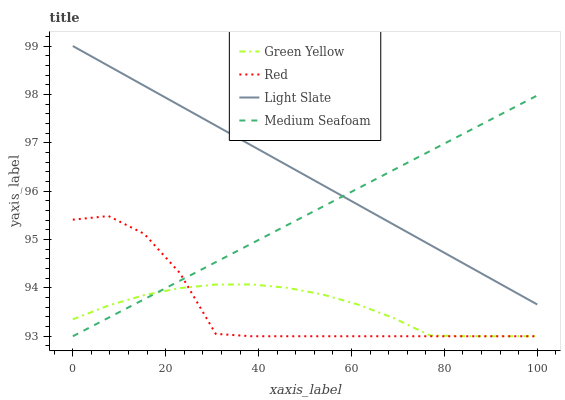Does Red have the minimum area under the curve?
Answer yes or no. Yes. Does Light Slate have the maximum area under the curve?
Answer yes or no. Yes. Does Green Yellow have the minimum area under the curve?
Answer yes or no. No. Does Green Yellow have the maximum area under the curve?
Answer yes or no. No. Is Medium Seafoam the smoothest?
Answer yes or no. Yes. Is Red the roughest?
Answer yes or no. Yes. Is Green Yellow the smoothest?
Answer yes or no. No. Is Green Yellow the roughest?
Answer yes or no. No. Does Green Yellow have the lowest value?
Answer yes or no. Yes. Does Light Slate have the highest value?
Answer yes or no. Yes. Does Medium Seafoam have the highest value?
Answer yes or no. No. Is Red less than Light Slate?
Answer yes or no. Yes. Is Light Slate greater than Green Yellow?
Answer yes or no. Yes. Does Red intersect Medium Seafoam?
Answer yes or no. Yes. Is Red less than Medium Seafoam?
Answer yes or no. No. Is Red greater than Medium Seafoam?
Answer yes or no. No. Does Red intersect Light Slate?
Answer yes or no. No. 